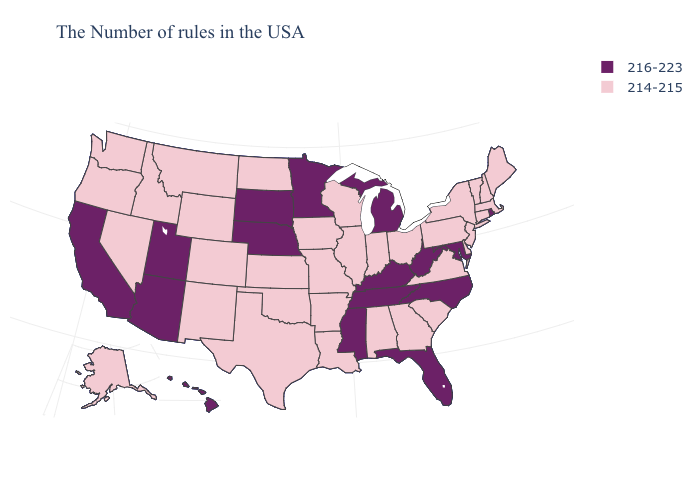Name the states that have a value in the range 216-223?
Quick response, please. Rhode Island, Maryland, North Carolina, West Virginia, Florida, Michigan, Kentucky, Tennessee, Mississippi, Minnesota, Nebraska, South Dakota, Utah, Arizona, California, Hawaii. What is the value of Tennessee?
Keep it brief. 216-223. Does Nevada have a lower value than North Dakota?
Write a very short answer. No. Among the states that border Oklahoma , which have the highest value?
Answer briefly. Missouri, Arkansas, Kansas, Texas, Colorado, New Mexico. Name the states that have a value in the range 216-223?
Concise answer only. Rhode Island, Maryland, North Carolina, West Virginia, Florida, Michigan, Kentucky, Tennessee, Mississippi, Minnesota, Nebraska, South Dakota, Utah, Arizona, California, Hawaii. Name the states that have a value in the range 214-215?
Short answer required. Maine, Massachusetts, New Hampshire, Vermont, Connecticut, New York, New Jersey, Delaware, Pennsylvania, Virginia, South Carolina, Ohio, Georgia, Indiana, Alabama, Wisconsin, Illinois, Louisiana, Missouri, Arkansas, Iowa, Kansas, Oklahoma, Texas, North Dakota, Wyoming, Colorado, New Mexico, Montana, Idaho, Nevada, Washington, Oregon, Alaska. Does Rhode Island have the highest value in the Northeast?
Answer briefly. Yes. What is the highest value in the USA?
Keep it brief. 216-223. Among the states that border Maryland , which have the highest value?
Give a very brief answer. West Virginia. What is the value of Maryland?
Short answer required. 216-223. Which states have the lowest value in the MidWest?
Answer briefly. Ohio, Indiana, Wisconsin, Illinois, Missouri, Iowa, Kansas, North Dakota. Among the states that border Maryland , does West Virginia have the lowest value?
Be succinct. No. Does Maine have the highest value in the Northeast?
Short answer required. No. Name the states that have a value in the range 216-223?
Short answer required. Rhode Island, Maryland, North Carolina, West Virginia, Florida, Michigan, Kentucky, Tennessee, Mississippi, Minnesota, Nebraska, South Dakota, Utah, Arizona, California, Hawaii. 